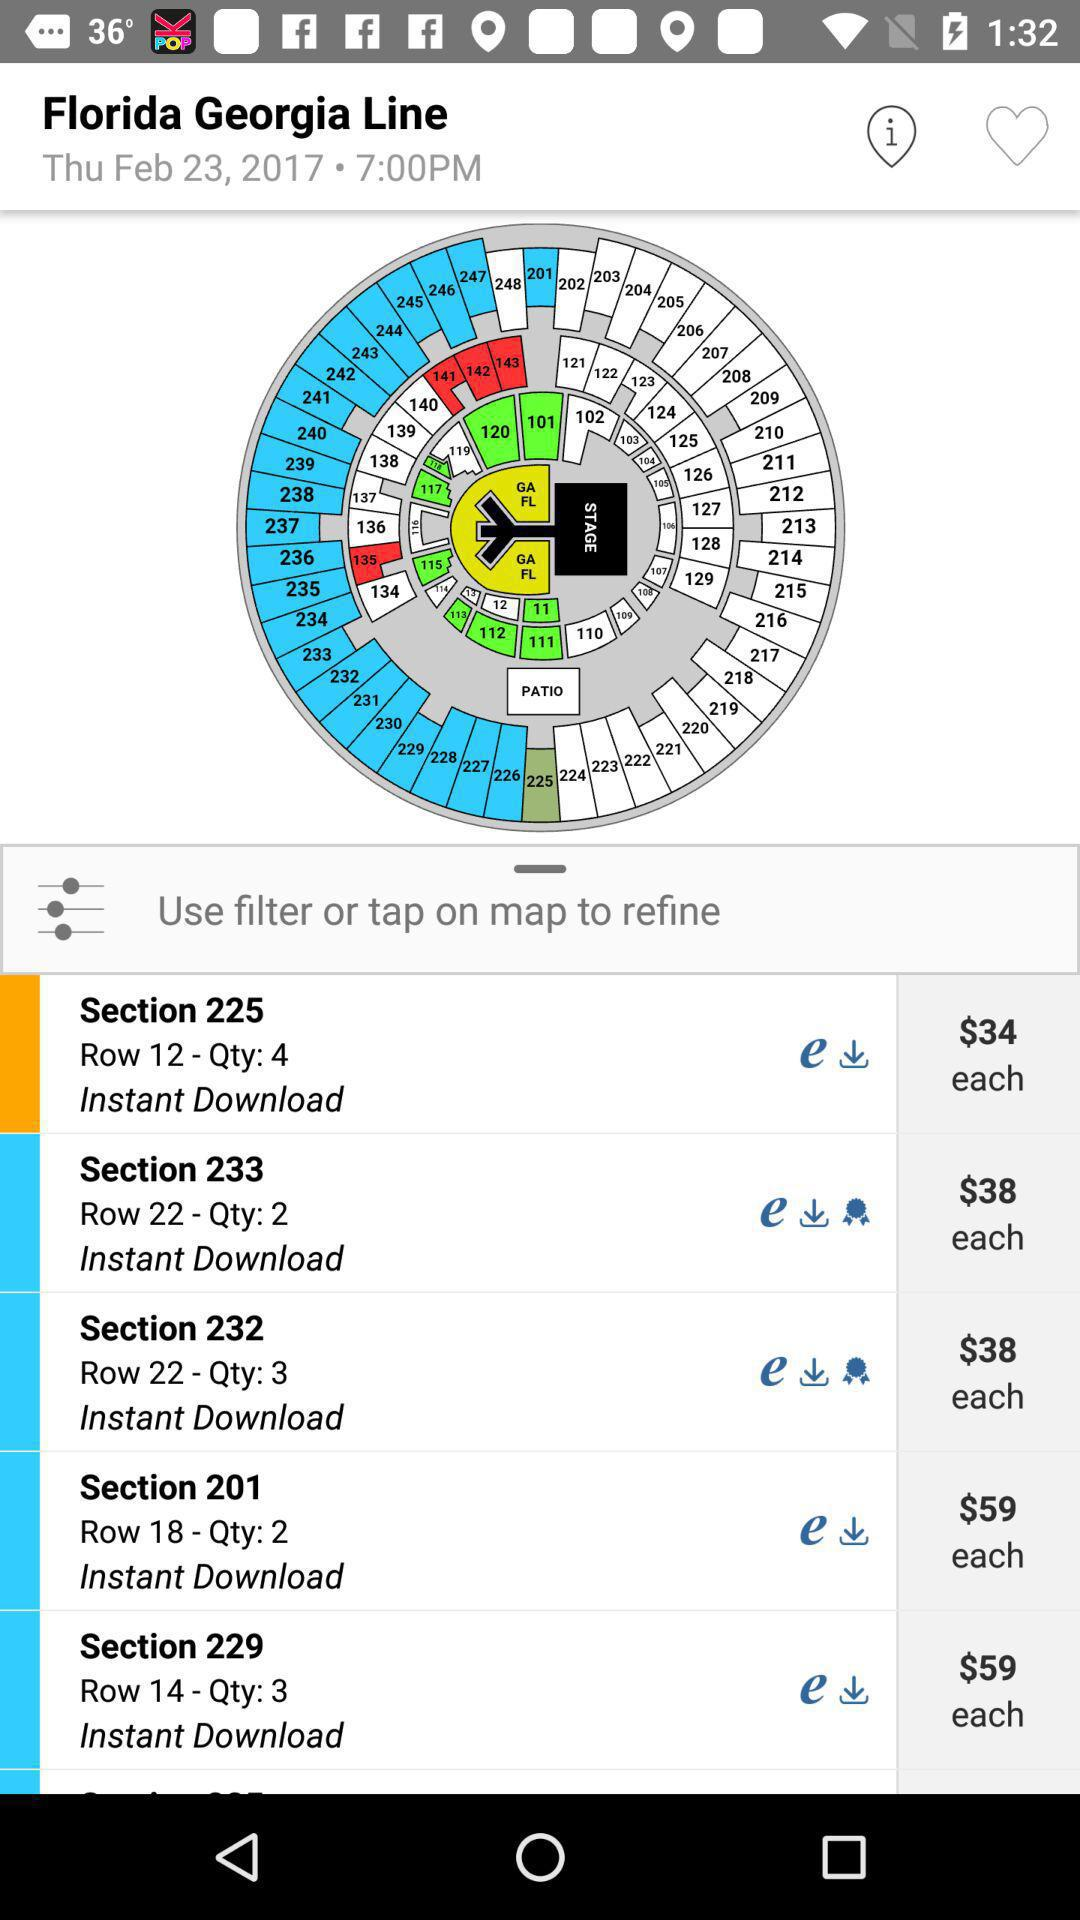What is the price of Section 225? The price of Section 225 is 34 dollars. 